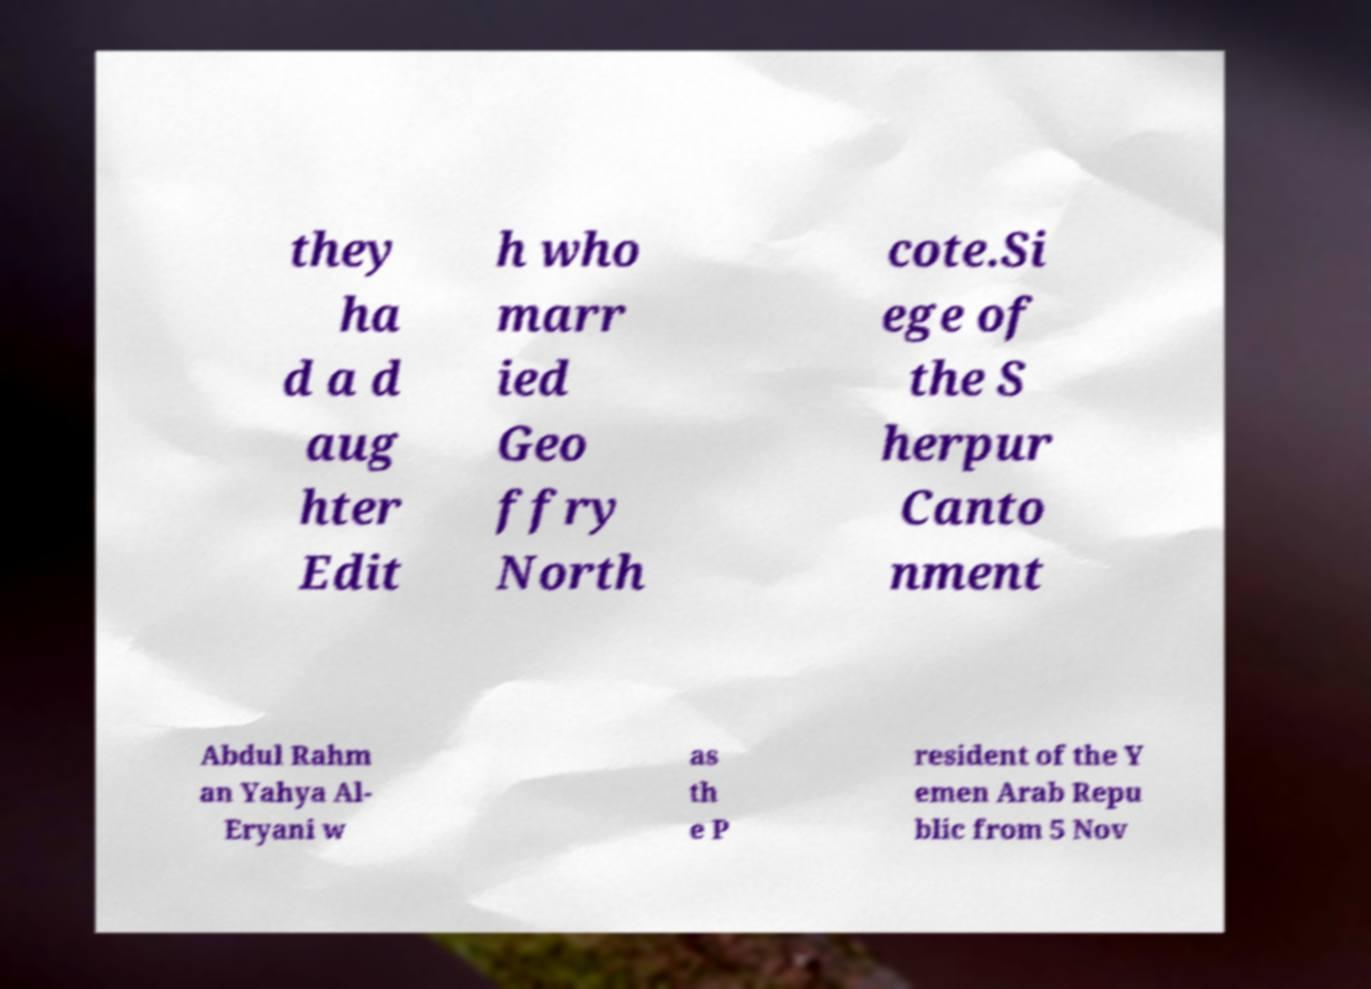Can you read and provide the text displayed in the image?This photo seems to have some interesting text. Can you extract and type it out for me? they ha d a d aug hter Edit h who marr ied Geo ffry North cote.Si ege of the S herpur Canto nment Abdul Rahm an Yahya Al- Eryani w as th e P resident of the Y emen Arab Repu blic from 5 Nov 